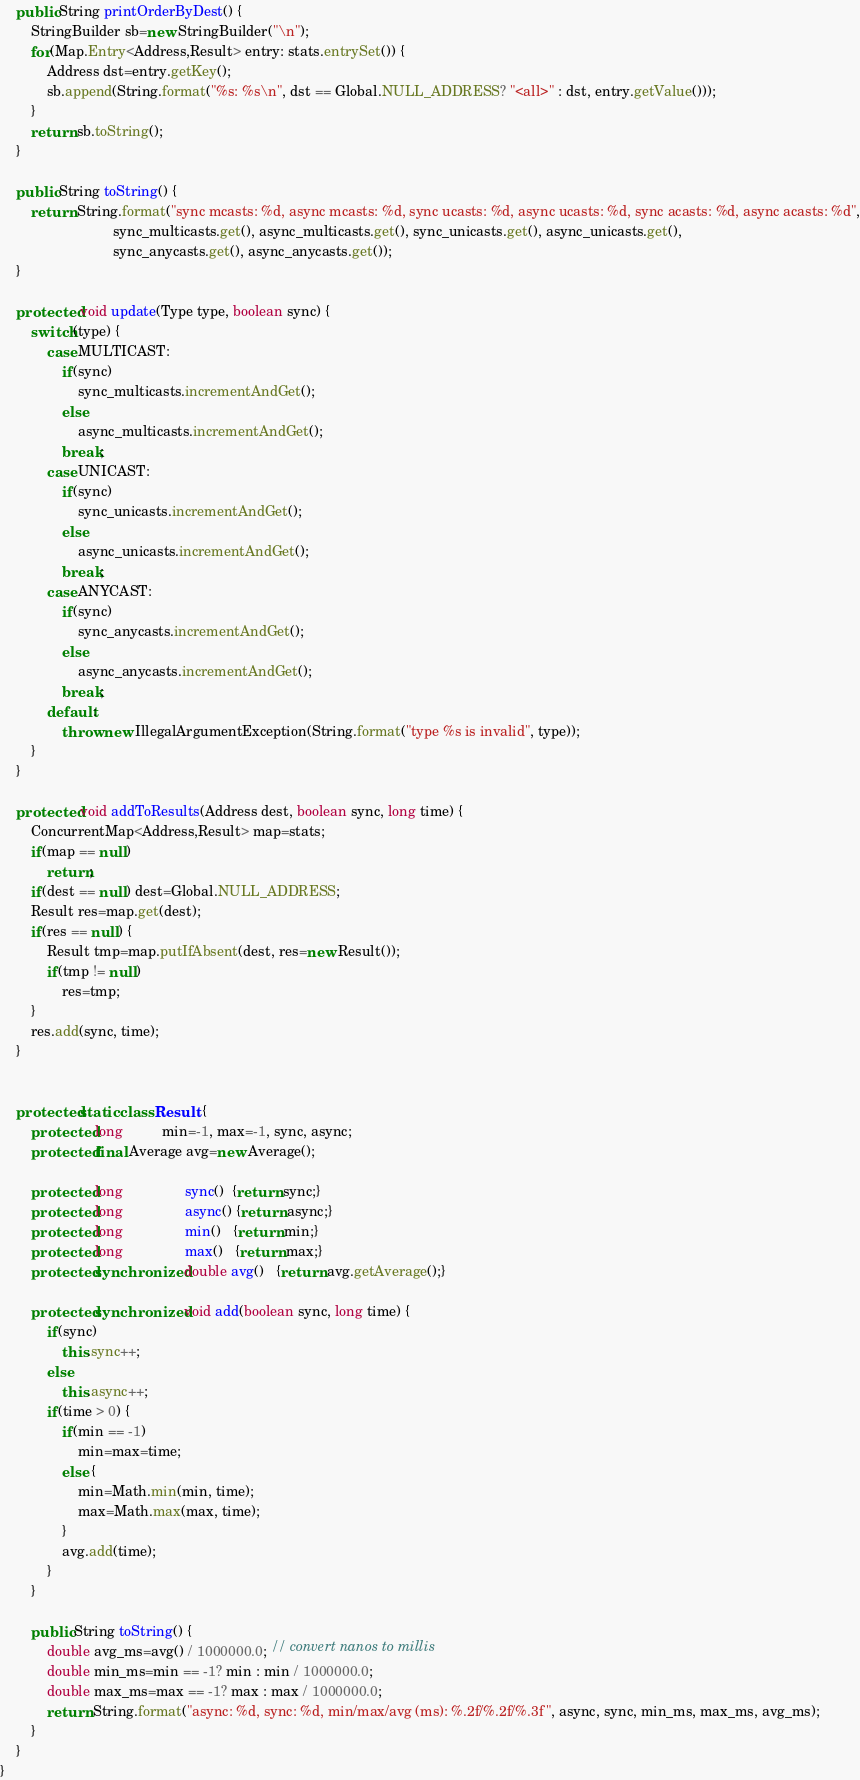Convert code to text. <code><loc_0><loc_0><loc_500><loc_500><_Java_>    public String printOrderByDest() {
        StringBuilder sb=new StringBuilder("\n");
        for(Map.Entry<Address,Result> entry: stats.entrySet()) {
            Address dst=entry.getKey();
            sb.append(String.format("%s: %s\n", dst == Global.NULL_ADDRESS? "<all>" : dst, entry.getValue()));
        }
        return sb.toString();
    }

    public String toString() {
        return String.format("sync mcasts: %d, async mcasts: %d, sync ucasts: %d, async ucasts: %d, sync acasts: %d, async acasts: %d",
                             sync_multicasts.get(), async_multicasts.get(), sync_unicasts.get(), async_unicasts.get(),
                             sync_anycasts.get(), async_anycasts.get());
    }

    protected void update(Type type, boolean sync) {
        switch(type) {
            case MULTICAST:
                if(sync)
                    sync_multicasts.incrementAndGet();
                else
                    async_multicasts.incrementAndGet();
                break;
            case UNICAST:
                if(sync)
                    sync_unicasts.incrementAndGet();
                else
                    async_unicasts.incrementAndGet();
                break;
            case ANYCAST:
                if(sync)
                    sync_anycasts.incrementAndGet();
                else
                    async_anycasts.incrementAndGet();
                break;
            default:
                throw new IllegalArgumentException(String.format("type %s is invalid", type));
        }
    }

    protected void addToResults(Address dest, boolean sync, long time) {
        ConcurrentMap<Address,Result> map=stats;
        if(map == null)
            return;
        if(dest == null) dest=Global.NULL_ADDRESS;
        Result res=map.get(dest);
        if(res == null) {
            Result tmp=map.putIfAbsent(dest, res=new Result());
            if(tmp != null)
                res=tmp;
        }
        res.add(sync, time);
    }


    protected static class Result {
        protected long          min=-1, max=-1, sync, async;
        protected final Average avg=new Average();

        protected long                sync()  {return sync;}
        protected long                async() {return async;}
        protected long                min()   {return min;}
        protected long                max()   {return max;}
        protected synchronized double avg()   {return avg.getAverage();}

        protected synchronized void add(boolean sync, long time) {
            if(sync)
                this.sync++;
            else
                this.async++;
            if(time > 0) {
                if(min == -1)
                    min=max=time;
                else {
                    min=Math.min(min, time);
                    max=Math.max(max, time);
                }
                avg.add(time);
            }
        }

        public String toString() {
            double avg_ms=avg() / 1000000.0; // convert nanos to millis
            double min_ms=min == -1? min : min / 1000000.0;
            double max_ms=max == -1? max : max / 1000000.0;
            return String.format("async: %d, sync: %d, min/max/avg (ms): %.2f/%.2f/%.3f", async, sync, min_ms, max_ms, avg_ms);
        }
    }
}
</code> 